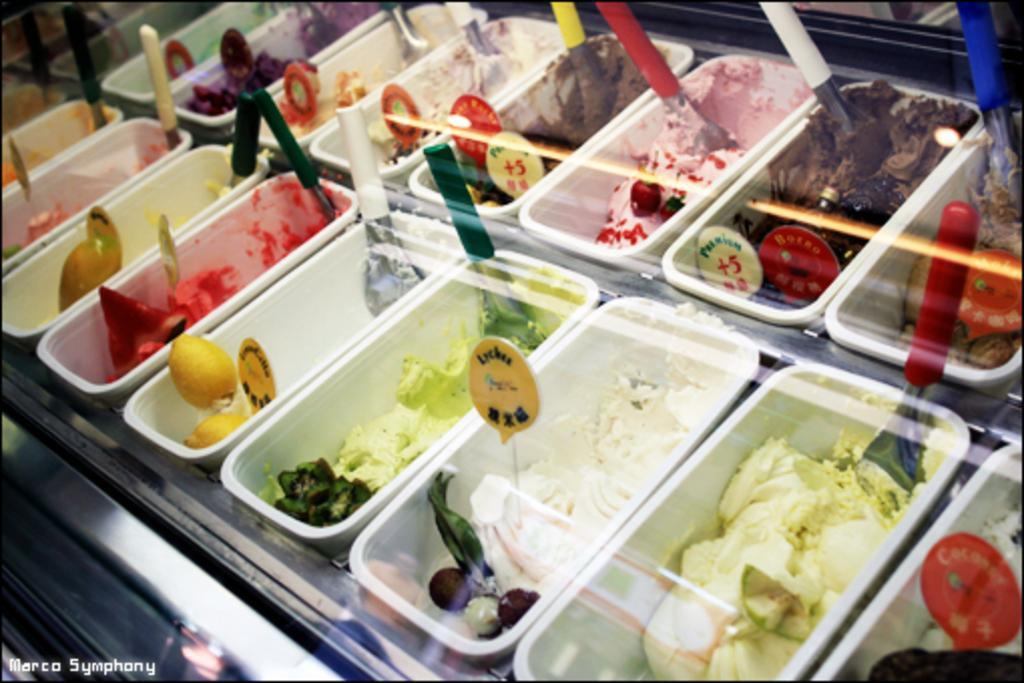What type of dessert is featured in the image? There are ice creams in the image. How are the ice creams packaged? The ice creams are in white boxes. What utensils are visible in the image? There are spoons visible in the image. What type of cracker is floating in space in the image? There is no cracker or space present in the image; it features ice creams in white boxes with spoons visible. 